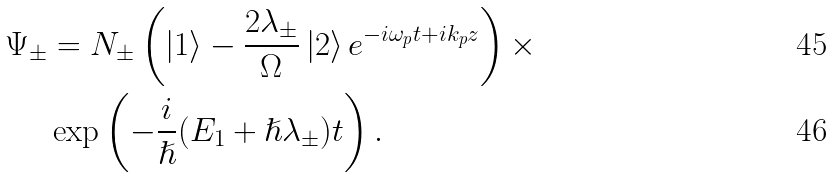Convert formula to latex. <formula><loc_0><loc_0><loc_500><loc_500>\Psi _ { \pm } & = N _ { \pm } \left ( \left | 1 \right \rangle - \frac { 2 \lambda _ { \pm } } { \Omega } \left | 2 \right \rangle e ^ { - i \omega _ { p } t + i k _ { p } z } \right ) \times \\ & \exp \left ( - \frac { i } { \hslash } ( E _ { 1 } + \hslash \lambda _ { \pm } ) t \right ) .</formula> 